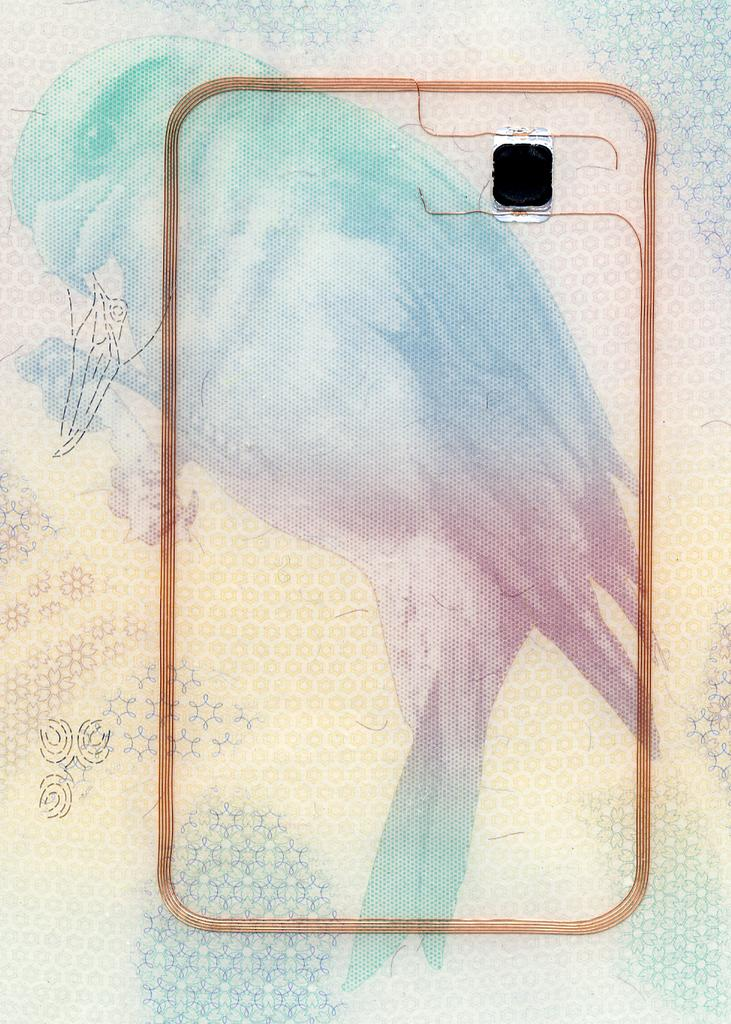What is depicted in the painting in the image? There is a painting of a bird in the image. Can you describe any other notable features in the image? There is a black colored spot in the image. What is the reaction of the bird to the hammer in the image? There is no hammer present in the image, so it is not possible to determine the bird's reaction to it. 